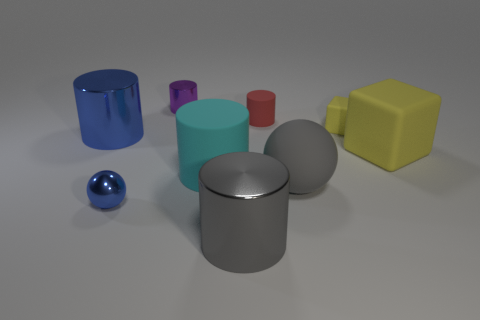Are there fewer gray cylinders left of the big yellow rubber block than big gray metal cylinders?
Provide a short and direct response. No. There is a large cyan thing that is the same shape as the red object; what is it made of?
Make the answer very short. Rubber. There is a metal thing that is both to the left of the tiny purple cylinder and behind the matte ball; what shape is it?
Ensure brevity in your answer.  Cylinder. The small yellow object that is the same material as the large gray ball is what shape?
Provide a short and direct response. Cube. There is a blue thing behind the large yellow cube; what material is it?
Provide a short and direct response. Metal. Do the yellow block that is behind the blue metal cylinder and the sphere that is to the right of the small blue thing have the same size?
Provide a succinct answer. No. The small ball has what color?
Ensure brevity in your answer.  Blue. There is a blue object behind the cyan cylinder; is its shape the same as the cyan rubber object?
Your response must be concise. Yes. What material is the tiny cube?
Provide a short and direct response. Rubber. The yellow matte thing that is the same size as the cyan matte cylinder is what shape?
Your answer should be compact. Cube. 